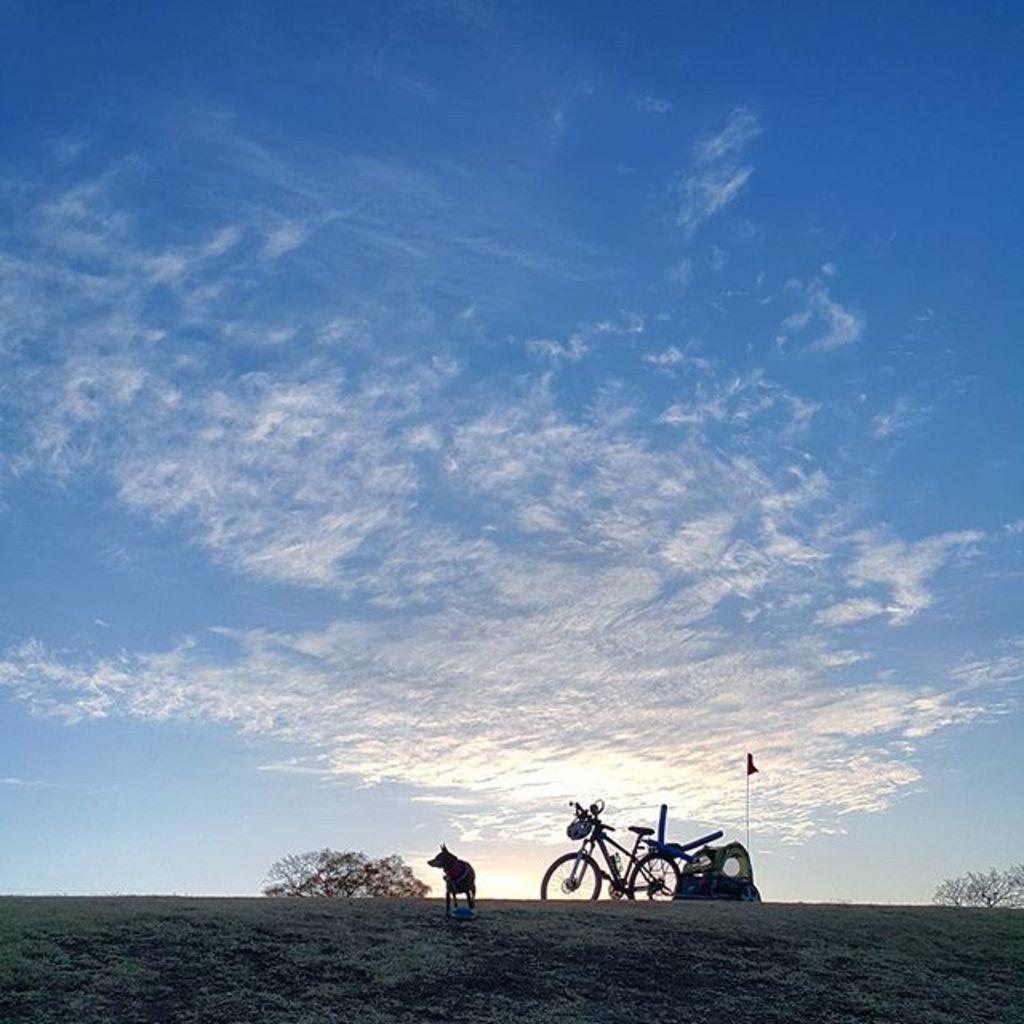Could you give a brief overview of what you see in this image? In this picture there is a dog, bicycle, and a flag at the bottom side of the image, it seems to be there is a tent in the image and there are trees at the bottom side of the image and there is sky in the image. 